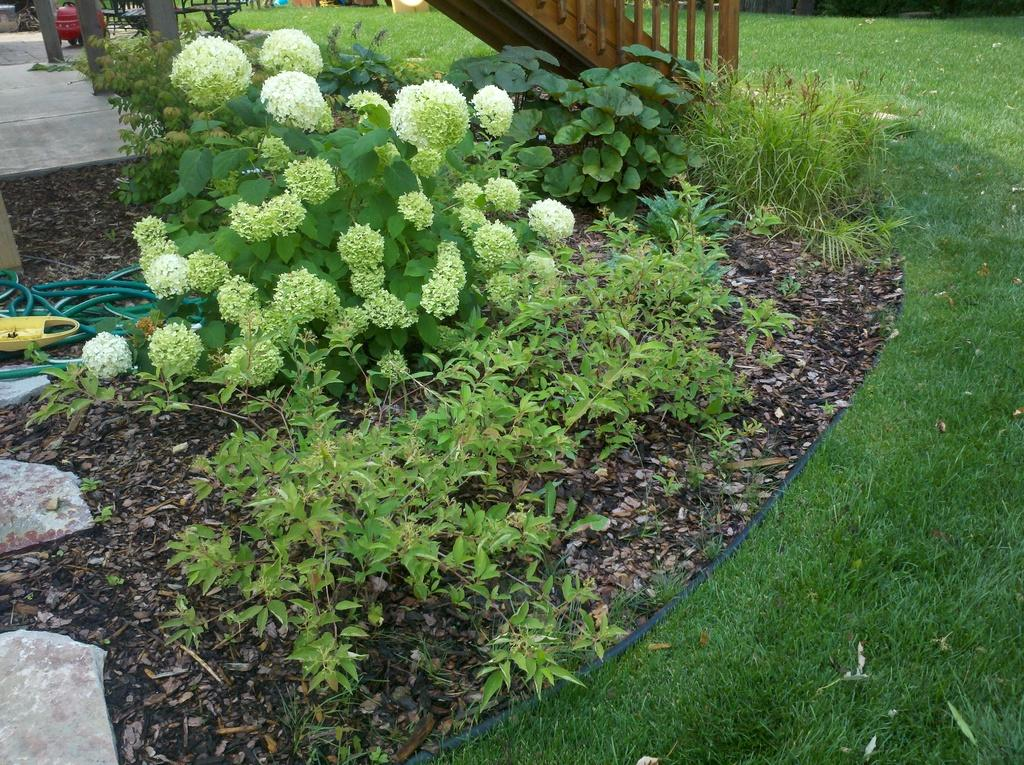What type of vegetation can be seen in the image? There are plants, flowers, and grass in the image. What architectural elements are present in the image? There are pillars and a grille in the image. What other objects can be seen in the image? There is a cable, stones, and leaves on the ground in the image. What type of quartz is present in the image? There is no quartz present in the image. What nation is represented by the plants in the image? The image does not represent any specific nation; it simply contains plants, flowers, and other objects. 